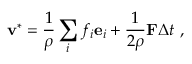Convert formula to latex. <formula><loc_0><loc_0><loc_500><loc_500>v ^ { * } = \frac { 1 } { \rho } \sum _ { i } f _ { i } e _ { i } + \frac { 1 } { 2 \rho } F \Delta t \ ,</formula> 